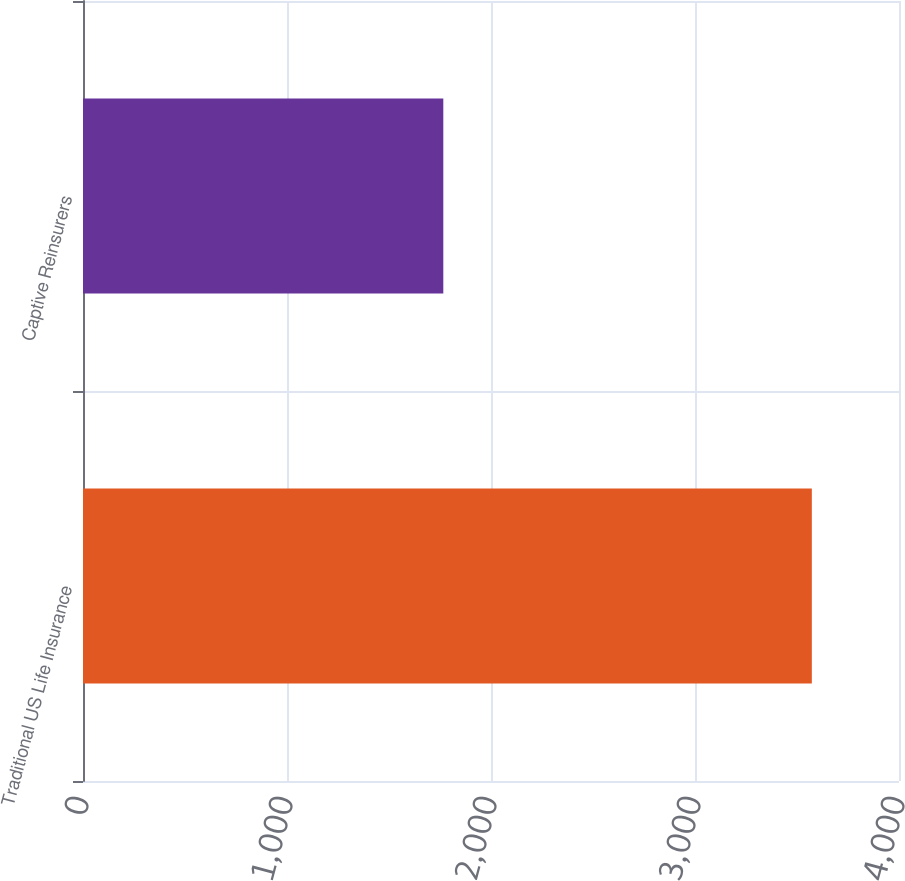Convert chart to OTSL. <chart><loc_0><loc_0><loc_500><loc_500><bar_chart><fcel>Traditional US Life Insurance<fcel>Captive Reinsurers<nl><fcel>3572.7<fcel>1766.2<nl></chart> 